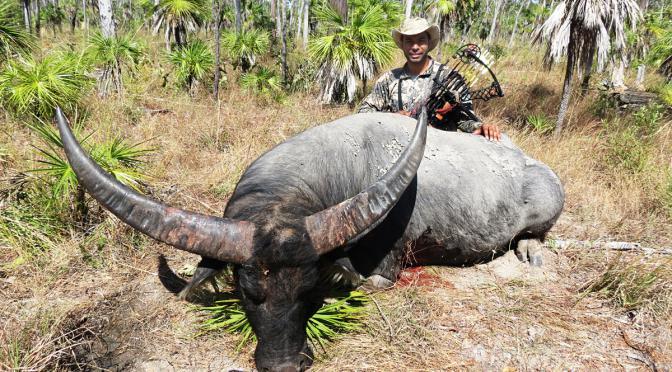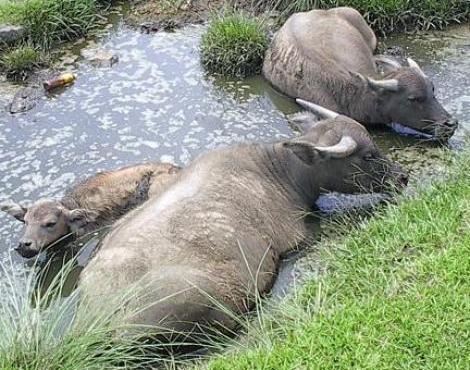The first image is the image on the left, the second image is the image on the right. Examine the images to the left and right. Is the description "In the left image, one horned animal looks directly at the camera." accurate? Answer yes or no. No. The first image is the image on the left, the second image is the image on the right. Examine the images to the left and right. Is the description "In one image, animals are standing in water beside a grassy area." accurate? Answer yes or no. Yes. 